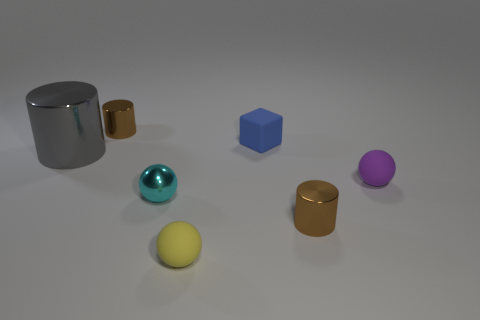There is another small matte object that is the same shape as the purple thing; what color is it? yellow 